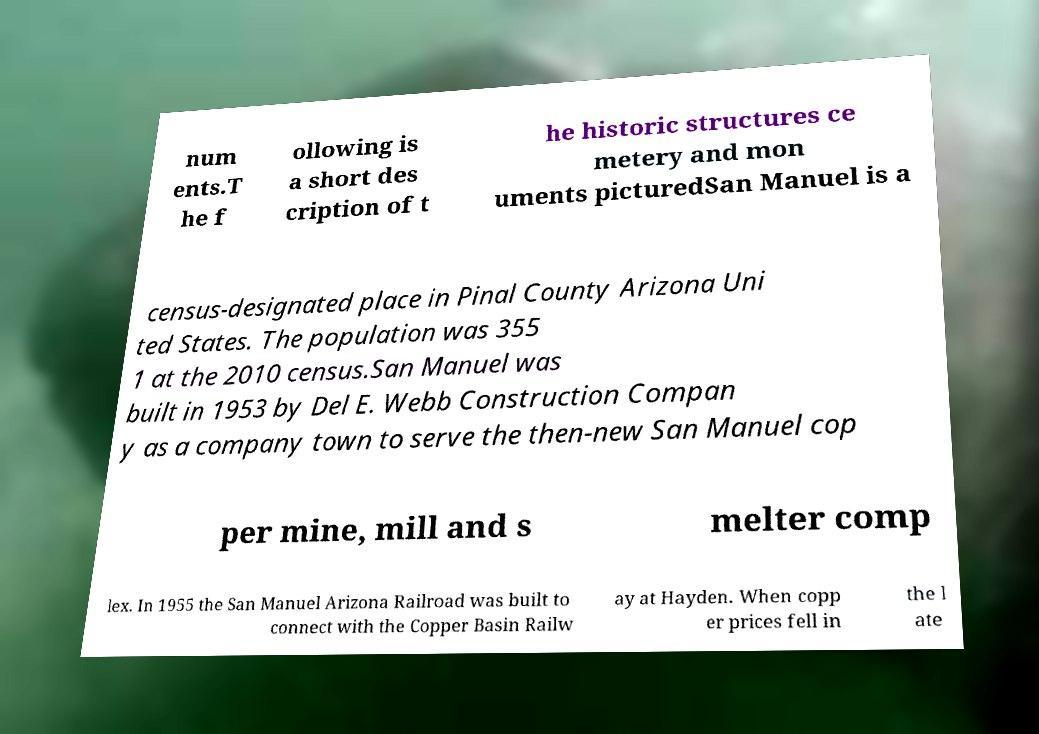Please identify and transcribe the text found in this image. num ents.T he f ollowing is a short des cription of t he historic structures ce metery and mon uments picturedSan Manuel is a census-designated place in Pinal County Arizona Uni ted States. The population was 355 1 at the 2010 census.San Manuel was built in 1953 by Del E. Webb Construction Compan y as a company town to serve the then-new San Manuel cop per mine, mill and s melter comp lex. In 1955 the San Manuel Arizona Railroad was built to connect with the Copper Basin Railw ay at Hayden. When copp er prices fell in the l ate 